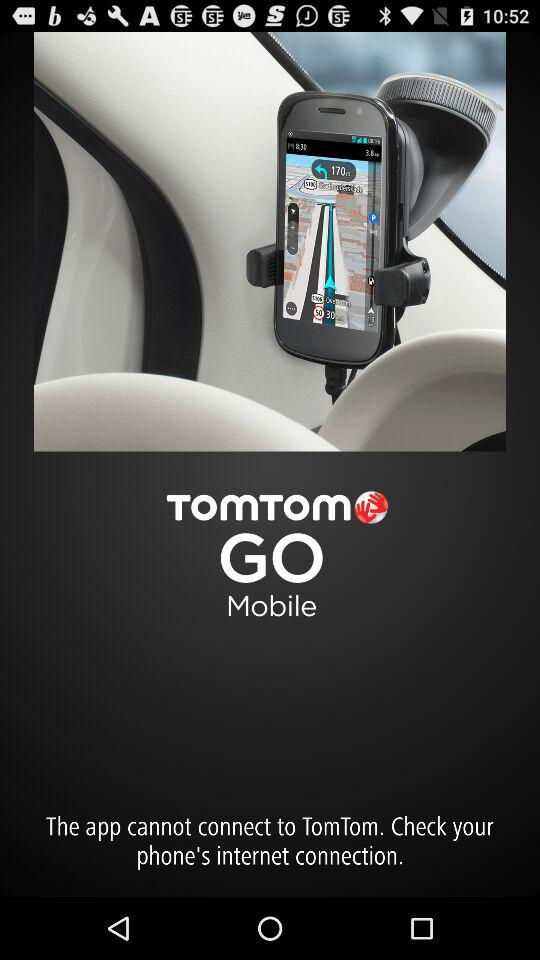What is the app name? The app name is "TomTom GO Mobile". 